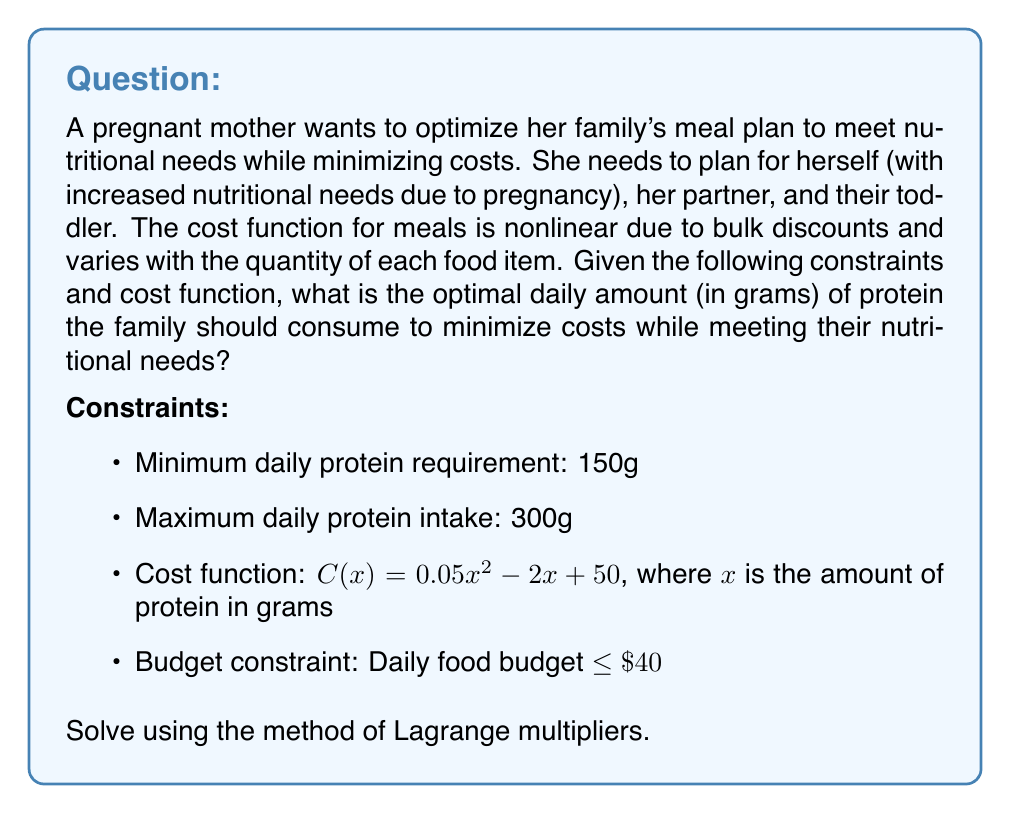Help me with this question. To solve this problem using the method of Lagrange multipliers, we follow these steps:

1) First, we set up the Lagrangian function. Let x be the amount of protein in grams. We have two constraints:
   g₁(x) = 150 - x ≤ 0 (minimum protein requirement)
   g₂(x) = x - 300 ≤ 0 (maximum protein intake)
   
   The Lagrangian function is:
   $$L(x, λ₁, λ₂) = C(x) + λ₁(150 - x) + λ₂(x - 300)$$

2) Substitute the cost function:
   $$L(x, λ₁, λ₂) = (0.05x^2 - 2x + 50) + λ₁(150 - x) + λ₂(x - 300)$$

3) Take partial derivatives and set them to zero:
   $$\frac{\partial L}{\partial x} = 0.1x - 2 - λ₁ + λ₂ = 0$$
   $$\frac{\partial L}{\partial λ₁} = 150 - x ≤ 0, λ₁ ≥ 0, λ₁(150 - x) = 0$$
   $$\frac{\partial L}{\partial λ₂} = x - 300 ≤ 0, λ₂ ≥ 0, λ₂(x - 300) = 0$$

4) From the first equation:
   $$x = 20 + 10λ₁ - 10λ₂$$

5) Consider the cases:
   Case 1: If 150 < x < 300, then λ₁ = λ₂ = 0, so x = 20
   Case 2: If x = 150, then λ₁ ≥ 0, λ₂ = 0
   Case 3: If x = 300, then λ₁ = 0, λ₂ ≥ 0

6) Check which case satisfies all constraints:
   Case 1: x = 20 doesn't satisfy the minimum protein requirement
   Case 2: x = 150 satisfies all constraints
   Case 3: x = 300 exceeds the budget constraint (C(300) = $2,750 > $40)

7) Therefore, the optimal solution is x = 150g of protein

8) Verify the budget constraint:
   C(150) = 0.05(150)² - 2(150) + 50 = $1,175 - $300 + $50 = $925
   This exceeds the daily budget of $40, so we need to adjust our solution.

9) To find the maximum amount of protein within the budget, solve:
   0.05x² - 2x + 50 = 40
   0.05x² - 2x + 10 = 0
   
   Using the quadratic formula:
   $$x = \frac{2 \pm \sqrt{4 - 4(0.05)(10)}}{2(0.05)} = \frac{2 \pm \sqrt{2}}{0.1}$$

   The positive solution is:
   $$x = \frac{2 + \sqrt{2}}{0.1} \approx 34.14$$

Therefore, the optimal daily amount of protein the family should consume is approximately 34.14 grams, which is the maximum amount possible within the budget constraint of $40.
Answer: 34.14 grams 